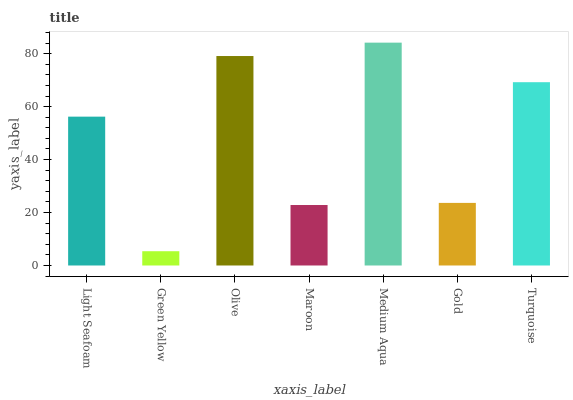Is Olive the minimum?
Answer yes or no. No. Is Olive the maximum?
Answer yes or no. No. Is Olive greater than Green Yellow?
Answer yes or no. Yes. Is Green Yellow less than Olive?
Answer yes or no. Yes. Is Green Yellow greater than Olive?
Answer yes or no. No. Is Olive less than Green Yellow?
Answer yes or no. No. Is Light Seafoam the high median?
Answer yes or no. Yes. Is Light Seafoam the low median?
Answer yes or no. Yes. Is Green Yellow the high median?
Answer yes or no. No. Is Olive the low median?
Answer yes or no. No. 